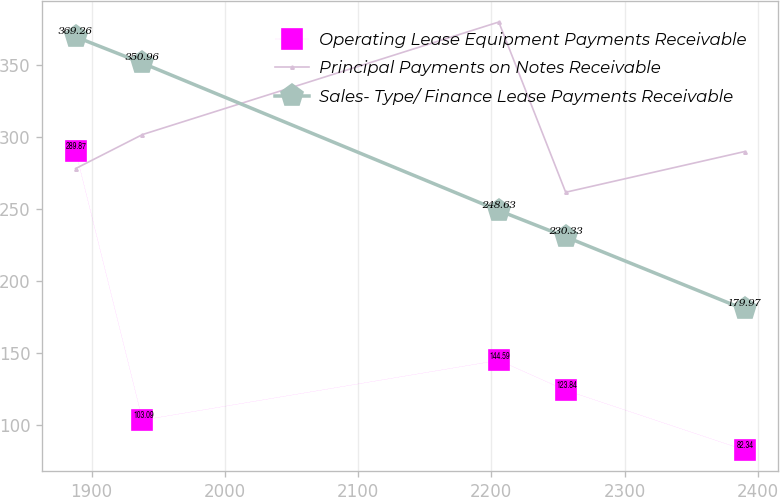Convert chart. <chart><loc_0><loc_0><loc_500><loc_500><line_chart><ecel><fcel>Operating Lease Equipment Payments Receivable<fcel>Principal Payments on Notes Receivable<fcel>Sales- Type/ Finance Lease Payments Receivable<nl><fcel>1887.96<fcel>289.87<fcel>277.75<fcel>369.26<nl><fcel>1938.17<fcel>103.09<fcel>301.39<fcel>350.96<nl><fcel>2205.56<fcel>144.59<fcel>379.54<fcel>248.63<nl><fcel>2255.77<fcel>123.84<fcel>261.32<fcel>230.33<nl><fcel>2390.02<fcel>82.34<fcel>289.57<fcel>179.97<nl></chart> 